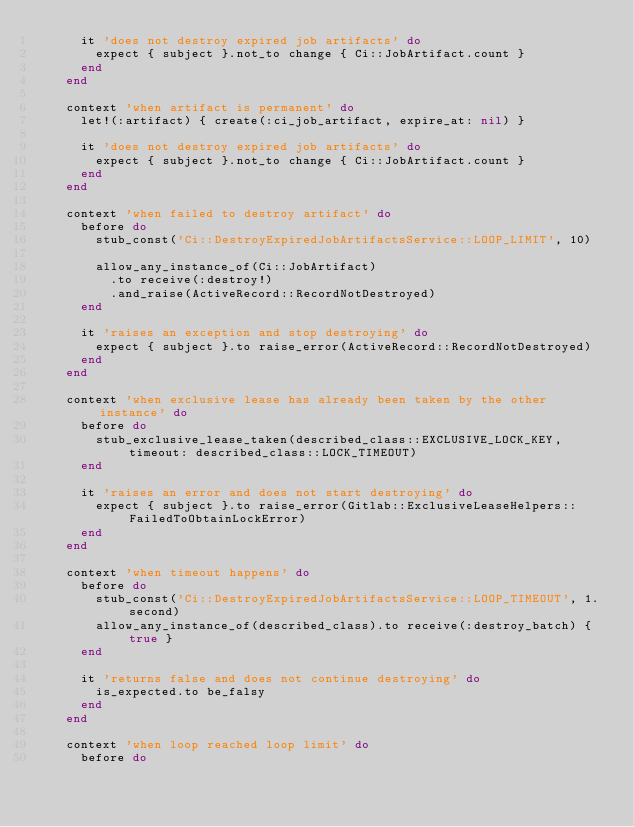Convert code to text. <code><loc_0><loc_0><loc_500><loc_500><_Ruby_>      it 'does not destroy expired job artifacts' do
        expect { subject }.not_to change { Ci::JobArtifact.count }
      end
    end

    context 'when artifact is permanent' do
      let!(:artifact) { create(:ci_job_artifact, expire_at: nil) }

      it 'does not destroy expired job artifacts' do
        expect { subject }.not_to change { Ci::JobArtifact.count }
      end
    end

    context 'when failed to destroy artifact' do
      before do
        stub_const('Ci::DestroyExpiredJobArtifactsService::LOOP_LIMIT', 10)

        allow_any_instance_of(Ci::JobArtifact)
          .to receive(:destroy!)
          .and_raise(ActiveRecord::RecordNotDestroyed)
      end

      it 'raises an exception and stop destroying' do
        expect { subject }.to raise_error(ActiveRecord::RecordNotDestroyed)
      end
    end

    context 'when exclusive lease has already been taken by the other instance' do
      before do
        stub_exclusive_lease_taken(described_class::EXCLUSIVE_LOCK_KEY, timeout: described_class::LOCK_TIMEOUT)
      end

      it 'raises an error and does not start destroying' do
        expect { subject }.to raise_error(Gitlab::ExclusiveLeaseHelpers::FailedToObtainLockError)
      end
    end

    context 'when timeout happens' do
      before do
        stub_const('Ci::DestroyExpiredJobArtifactsService::LOOP_TIMEOUT', 1.second)
        allow_any_instance_of(described_class).to receive(:destroy_batch) { true }
      end

      it 'returns false and does not continue destroying' do
        is_expected.to be_falsy
      end
    end

    context 'when loop reached loop limit' do
      before do</code> 